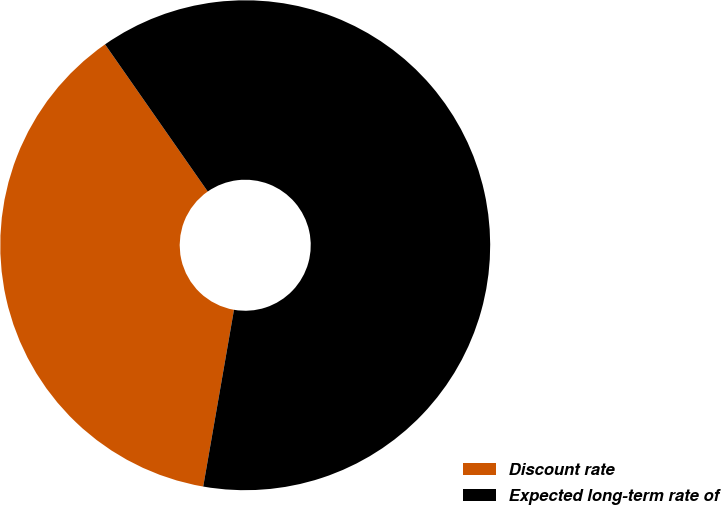Convert chart. <chart><loc_0><loc_0><loc_500><loc_500><pie_chart><fcel>Discount rate<fcel>Expected long-term rate of<nl><fcel>37.56%<fcel>62.44%<nl></chart> 